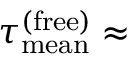<formula> <loc_0><loc_0><loc_500><loc_500>\tau _ { m e a n } ^ { ( f r e e ) } \approx</formula> 